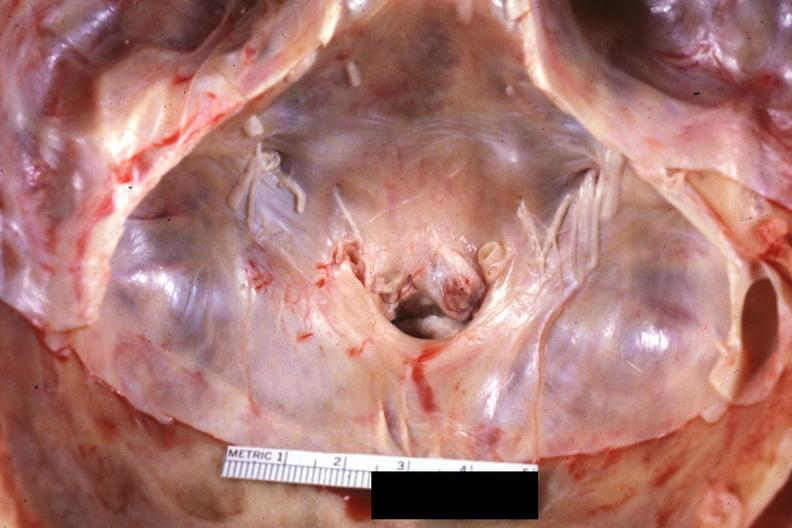what is present?
Answer the question using a single word or phrase. Bone, calvarium 